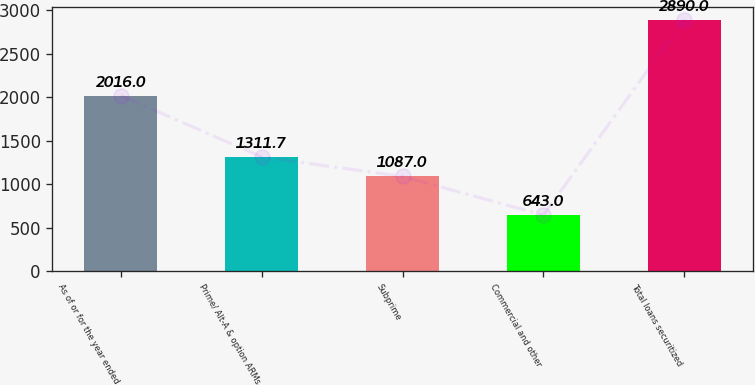Convert chart. <chart><loc_0><loc_0><loc_500><loc_500><bar_chart><fcel>As of or for the year ended<fcel>Prime/ Alt-A & option ARMs<fcel>Subprime<fcel>Commercial and other<fcel>Total loans securitized<nl><fcel>2016<fcel>1311.7<fcel>1087<fcel>643<fcel>2890<nl></chart> 